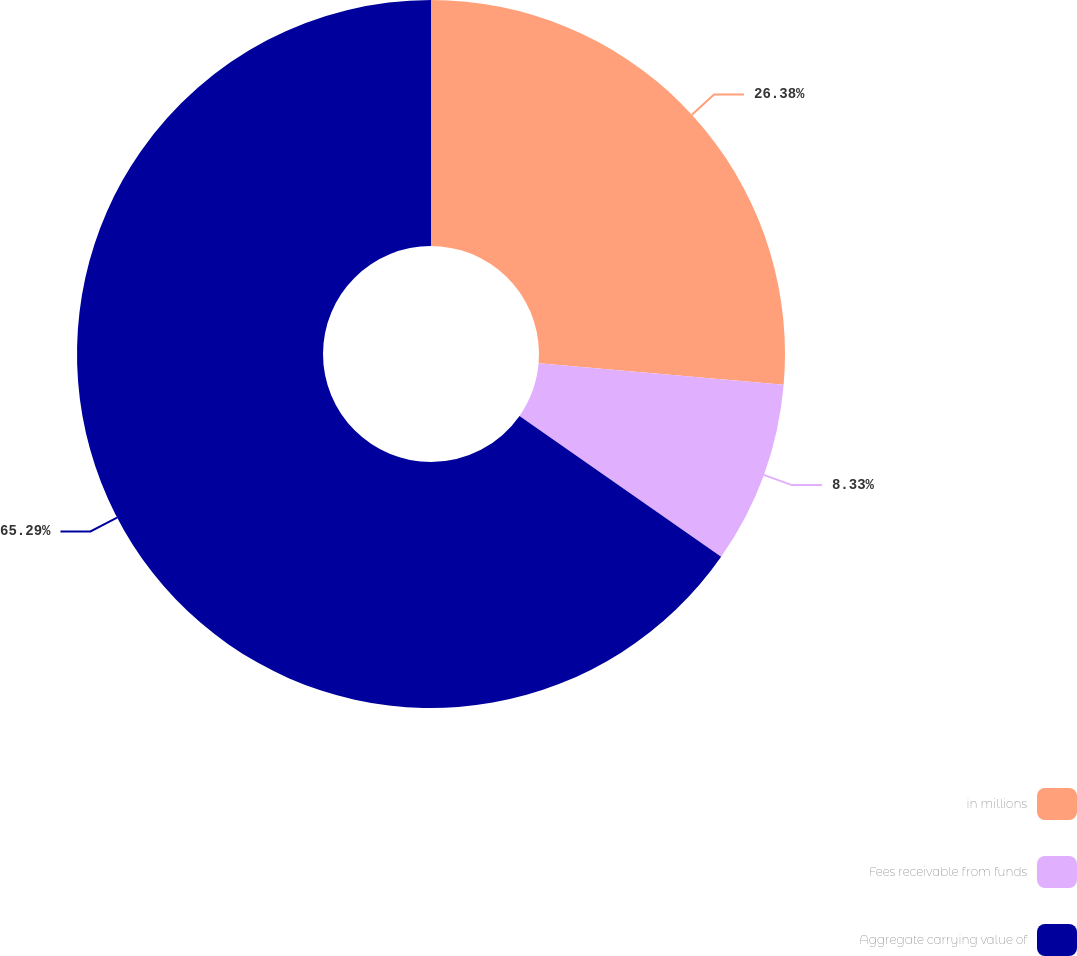<chart> <loc_0><loc_0><loc_500><loc_500><pie_chart><fcel>in millions<fcel>Fees receivable from funds<fcel>Aggregate carrying value of<nl><fcel>26.38%<fcel>8.33%<fcel>65.29%<nl></chart> 